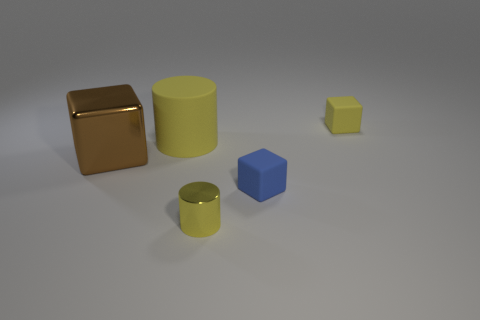Subtract all tiny blue matte cubes. How many cubes are left? 2 Subtract all yellow blocks. How many blocks are left? 2 Subtract 1 cylinders. How many cylinders are left? 1 Add 3 brown metallic things. How many objects exist? 8 Subtract all cylinders. How many objects are left? 3 Subtract all red cylinders. How many blue blocks are left? 1 Subtract all yellow metal cylinders. Subtract all cylinders. How many objects are left? 2 Add 4 small blue matte cubes. How many small blue matte cubes are left? 5 Add 1 blue cubes. How many blue cubes exist? 2 Subtract 1 yellow cylinders. How many objects are left? 4 